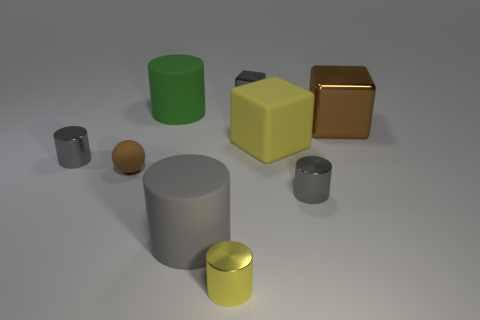Subtract all gray cylinders. How many were subtracted if there are1gray cylinders left? 2 Subtract all small gray metal cylinders. How many cylinders are left? 3 Subtract all blue spheres. How many gray cylinders are left? 3 Subtract all green cylinders. How many cylinders are left? 4 Subtract 2 cubes. How many cubes are left? 1 Subtract all balls. How many objects are left? 8 Subtract 1 gray cylinders. How many objects are left? 8 Subtract all yellow blocks. Subtract all gray spheres. How many blocks are left? 2 Subtract all yellow matte blocks. Subtract all gray shiny things. How many objects are left? 5 Add 7 big cylinders. How many big cylinders are left? 9 